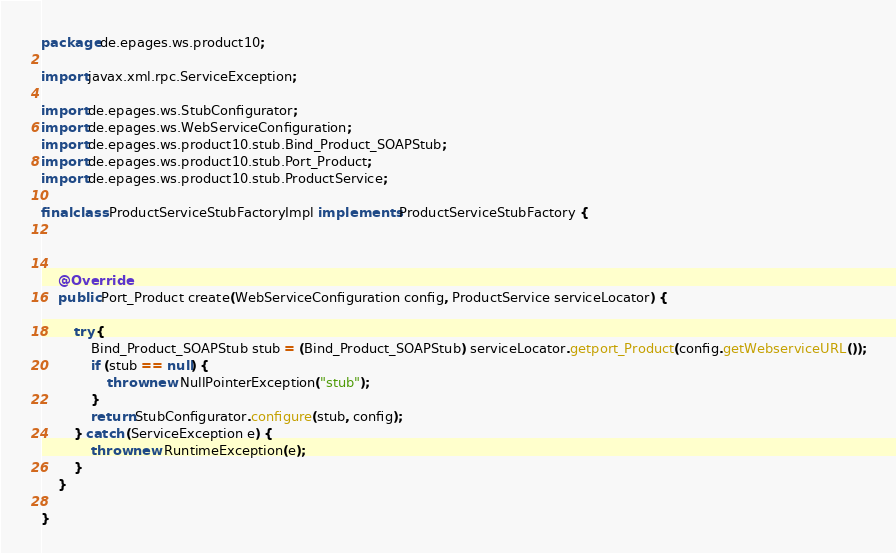<code> <loc_0><loc_0><loc_500><loc_500><_Java_>package de.epages.ws.product10;

import javax.xml.rpc.ServiceException;

import de.epages.ws.StubConfigurator;
import de.epages.ws.WebServiceConfiguration;
import de.epages.ws.product10.stub.Bind_Product_SOAPStub;
import de.epages.ws.product10.stub.Port_Product;
import de.epages.ws.product10.stub.ProductService;

final class ProductServiceStubFactoryImpl implements ProductServiceStubFactory {



    @Override
    public Port_Product create(WebServiceConfiguration config, ProductService serviceLocator) {
        
        try {
            Bind_Product_SOAPStub stub = (Bind_Product_SOAPStub) serviceLocator.getport_Product(config.getWebserviceURL());
            if (stub == null) {
                throw new NullPointerException("stub");
            }
            return StubConfigurator.configure(stub, config);
        } catch (ServiceException e) {
            throw new RuntimeException(e);
        }
    }

}</code> 